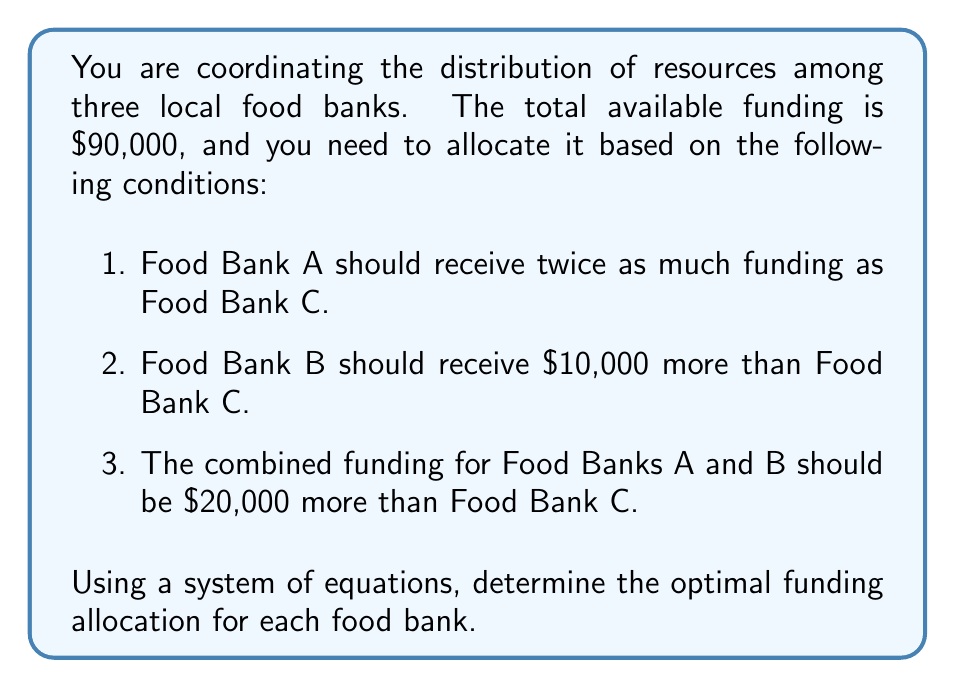Teach me how to tackle this problem. Let's approach this problem step-by-step using a system of equations:

1. Let's define our variables:
   $x$ = funding for Food Bank A
   $y$ = funding for Food Bank B
   $z$ = funding for Food Bank C

2. Now, we can set up our equations based on the given conditions:

   Equation 1: $x = 2z$ (Food Bank A receives twice as much as C)
   Equation 2: $y = z + 10000$ (Food Bank B receives $10,000 more than C)
   Equation 3: $x + y = z + 20000$ (A and B combined receive $20,000 more than C)
   Equation 4: $x + y + z = 90000$ (Total funding is $90,000)

3. Let's substitute Equation 1 and Equation 2 into Equation 3:

   $2z + (z + 10000) = z + 20000$
   $3z + 10000 = z + 20000$
   $2z = 10000$
   $z = 5000$

4. Now that we know $z$, we can find $x$ and $y$:

   $x = 2z = 2(5000) = 10000$
   $y = z + 10000 = 5000 + 10000 = 15000$

5. Let's verify our solution using Equation 4:

   $x + y + z = 10000 + 15000 + 5000 = 30000$

   This equals our total funding of $90,000, so our solution is correct.

Therefore, the optimal funding allocation is:
Food Bank A: $10,000
Food Bank B: $15,000
Food Bank C: $5,000
Answer: Food Bank A: $10,000
Food Bank B: $15,000
Food Bank C: $5,000 